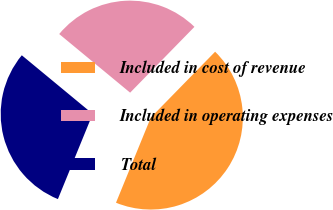Convert chart to OTSL. <chart><loc_0><loc_0><loc_500><loc_500><pie_chart><fcel>Included in cost of revenue<fcel>Included in operating expenses<fcel>Total<nl><fcel>43.86%<fcel>26.32%<fcel>29.82%<nl></chart> 